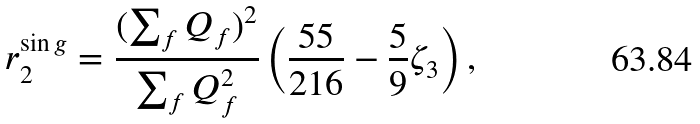<formula> <loc_0><loc_0><loc_500><loc_500>r _ { 2 } ^ { \sin g } = \frac { ( \sum _ { f } Q _ { f } ) ^ { 2 } } { \sum _ { f } Q _ { f } ^ { 2 } } \left ( \frac { 5 5 } { 2 1 6 } - \frac { 5 } { 9 } \zeta _ { 3 } \right ) ,</formula> 